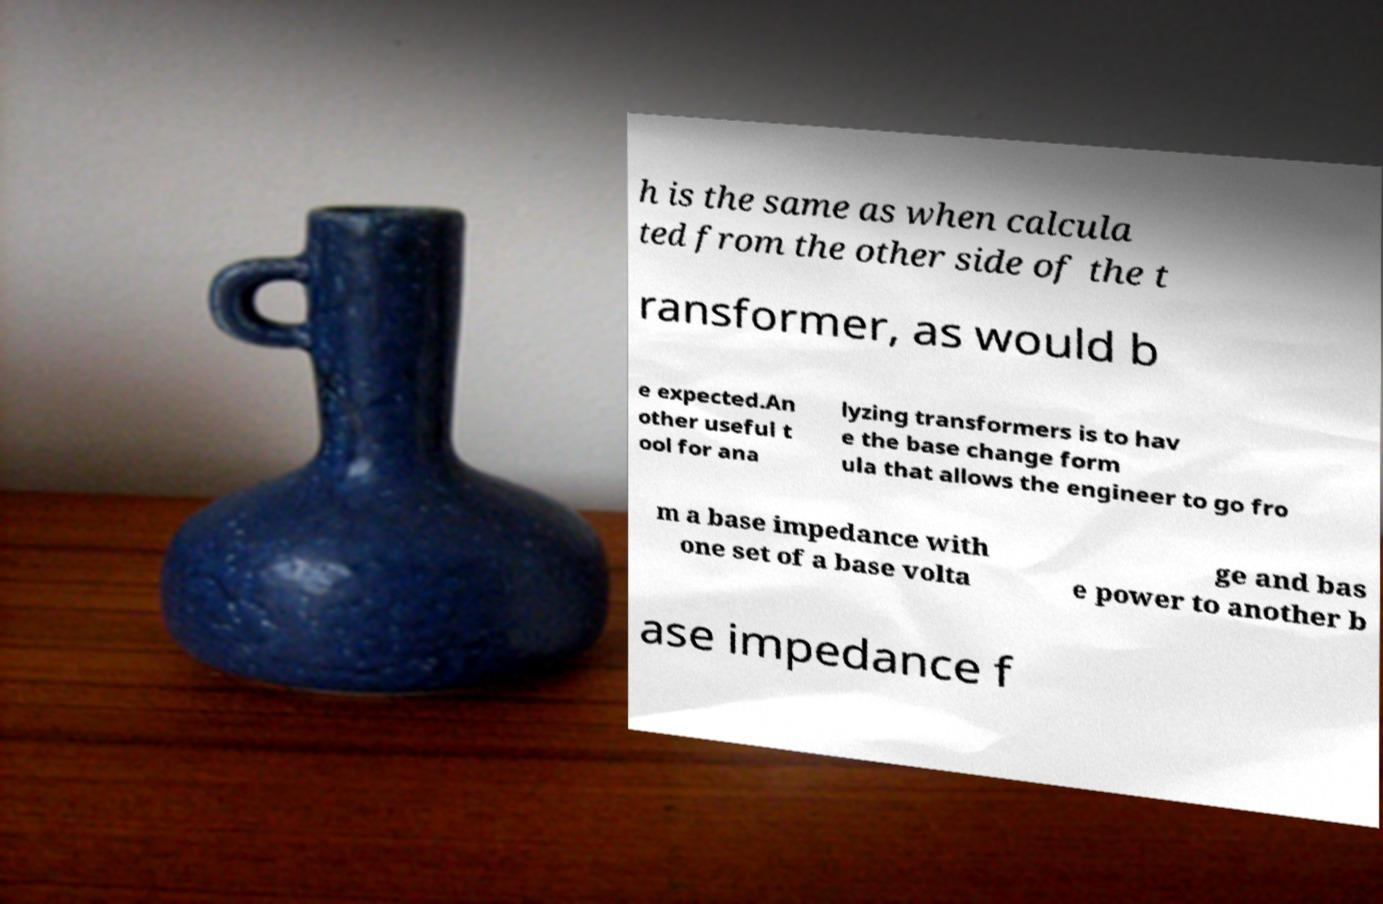For documentation purposes, I need the text within this image transcribed. Could you provide that? h is the same as when calcula ted from the other side of the t ransformer, as would b e expected.An other useful t ool for ana lyzing transformers is to hav e the base change form ula that allows the engineer to go fro m a base impedance with one set of a base volta ge and bas e power to another b ase impedance f 